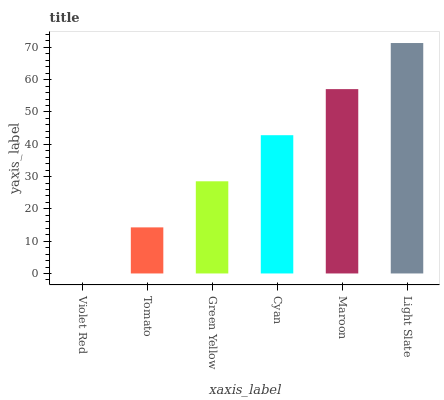Is Violet Red the minimum?
Answer yes or no. Yes. Is Light Slate the maximum?
Answer yes or no. Yes. Is Tomato the minimum?
Answer yes or no. No. Is Tomato the maximum?
Answer yes or no. No. Is Tomato greater than Violet Red?
Answer yes or no. Yes. Is Violet Red less than Tomato?
Answer yes or no. Yes. Is Violet Red greater than Tomato?
Answer yes or no. No. Is Tomato less than Violet Red?
Answer yes or no. No. Is Cyan the high median?
Answer yes or no. Yes. Is Green Yellow the low median?
Answer yes or no. Yes. Is Light Slate the high median?
Answer yes or no. No. Is Light Slate the low median?
Answer yes or no. No. 